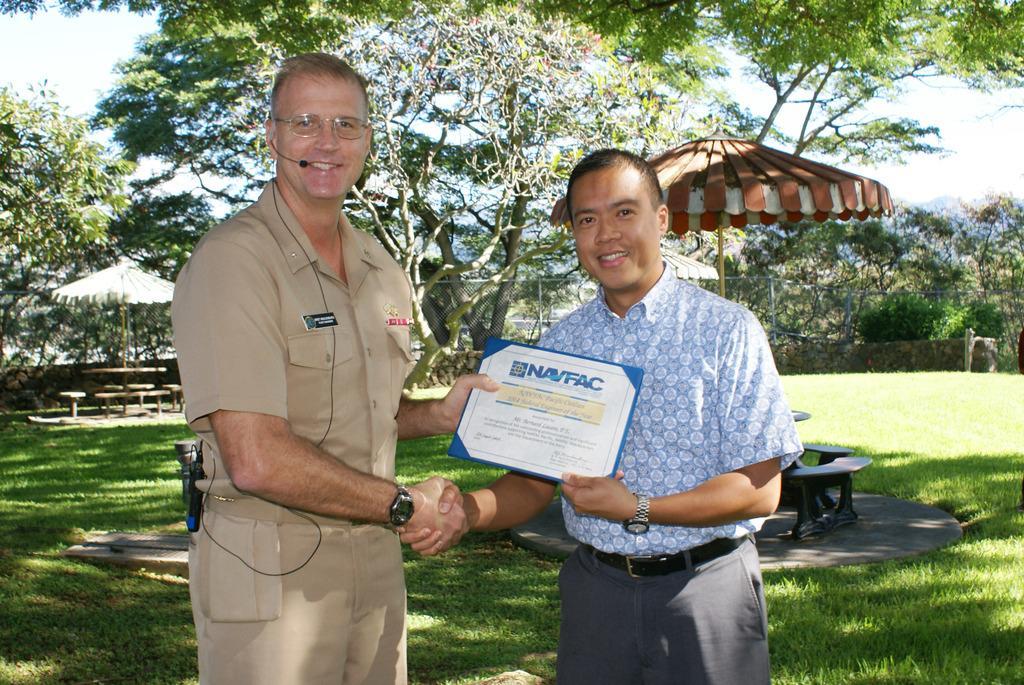Could you give a brief overview of what you see in this image? In this picture I can see two men are standing and shaking their hands in the middle and also they are holding the card, in the background there are trees, umbrellas, benches at the top there is the sky. 